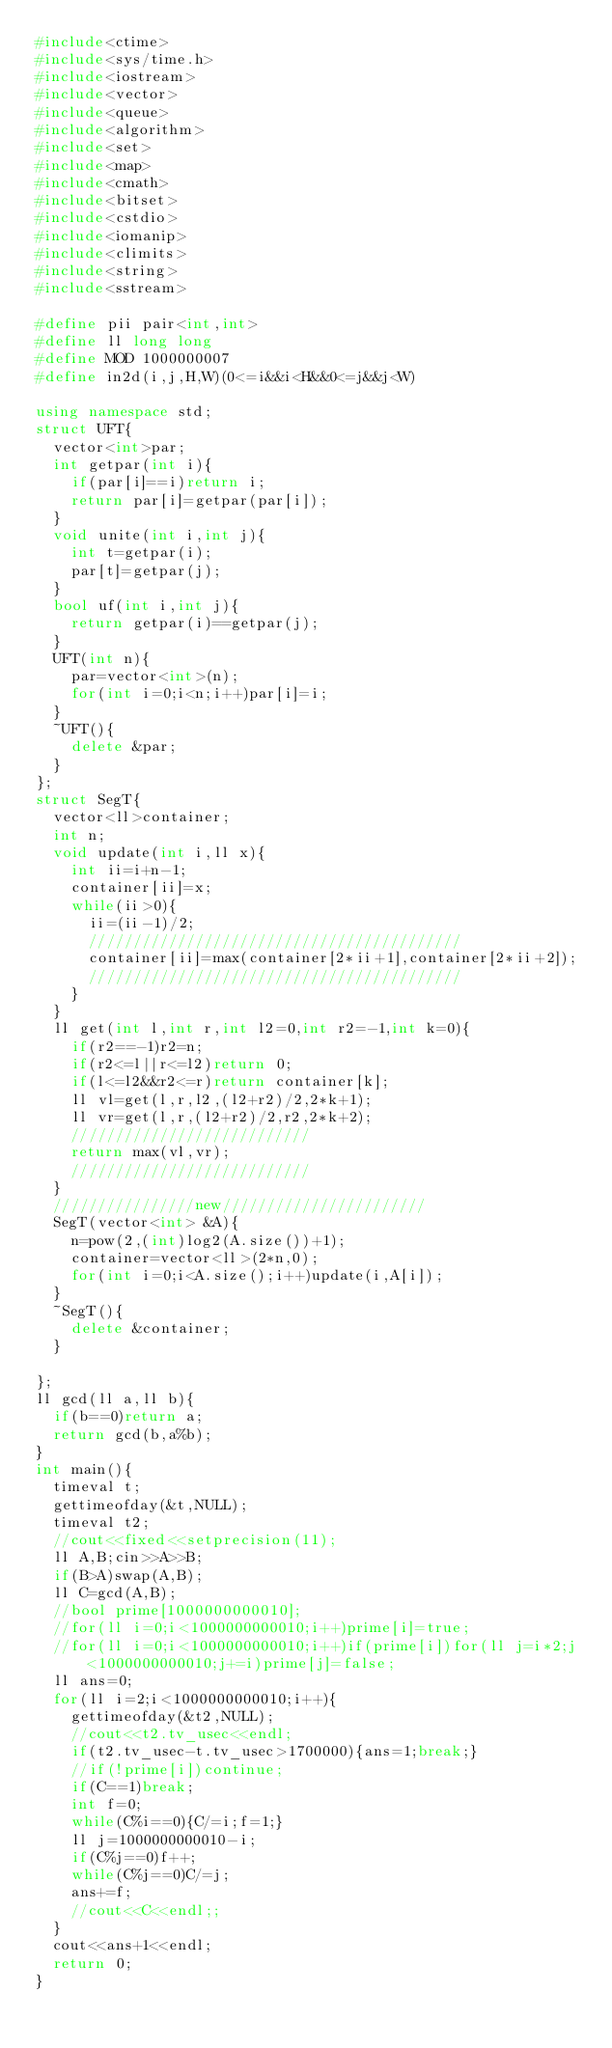<code> <loc_0><loc_0><loc_500><loc_500><_C++_>#include<ctime>
#include<sys/time.h>
#include<iostream>
#include<vector>
#include<queue>
#include<algorithm>
#include<set>
#include<map>
#include<cmath>
#include<bitset>
#include<cstdio>
#include<iomanip>
#include<climits>
#include<string>
#include<sstream>

#define pii pair<int,int>
#define ll long long
#define MOD 1000000007
#define in2d(i,j,H,W)(0<=i&&i<H&&0<=j&&j<W)

using namespace std;
struct UFT{
	vector<int>par;
	int getpar(int i){
		if(par[i]==i)return i;
		return par[i]=getpar(par[i]);
	}
	void unite(int i,int j){
		int t=getpar(i);
		par[t]=getpar(j);
	}
	bool uf(int i,int j){
		return getpar(i)==getpar(j);
	}
	UFT(int n){
		par=vector<int>(n);
		for(int i=0;i<n;i++)par[i]=i;
	}
	~UFT(){
		delete &par;
	}
};
struct SegT{
	vector<ll>container;
	int n;
	void update(int i,ll x){
		int ii=i+n-1;
		container[ii]=x;
		while(ii>0){
			ii=(ii-1)/2;
			//////////////////////////////////////////
			container[ii]=max(container[2*ii+1],container[2*ii+2]);
			//////////////////////////////////////////
		}
	}
	ll get(int l,int r,int l2=0,int r2=-1,int k=0){
		if(r2==-1)r2=n;
		if(r2<=l||r<=l2)return 0;
		if(l<=l2&&r2<=r)return container[k];
		ll vl=get(l,r,l2,(l2+r2)/2,2*k+1);
		ll vr=get(l,r,(l2+r2)/2,r2,2*k+2);
		///////////////////////////
		return max(vl,vr);
		///////////////////////////
	}
	////////////////new///////////////////////
	SegT(vector<int> &A){
		n=pow(2,(int)log2(A.size())+1);
		container=vector<ll>(2*n,0);
		for(int i=0;i<A.size();i++)update(i,A[i]);
	}
	~SegT(){
		delete &container;
	}

};
ll gcd(ll a,ll b){
	if(b==0)return a;
	return gcd(b,a%b);
}
int main(){
	timeval t;
	gettimeofday(&t,NULL);
	timeval t2;
	//cout<<fixed<<setprecision(11);
	ll A,B;cin>>A>>B;
	if(B>A)swap(A,B);
	ll C=gcd(A,B);
	//bool prime[1000000000010];
	//for(ll i=0;i<1000000000010;i++)prime[i]=true;
	//for(ll i=0;i<1000000000010;i++)if(prime[i])for(ll j=i*2;j<1000000000010;j+=i)prime[j]=false;
	ll ans=0;
	for(ll i=2;i<1000000000010;i++){
		gettimeofday(&t2,NULL);
		//cout<<t2.tv_usec<<endl;
		if(t2.tv_usec-t.tv_usec>1700000){ans=1;break;}
		//if(!prime[i])continue;
		if(C==1)break;
		int f=0;
		while(C%i==0){C/=i;f=1;}
		ll j=1000000000010-i;
		if(C%j==0)f++;
		while(C%j==0)C/=j;
		ans+=f;
		//cout<<C<<endl;;
	}
	cout<<ans+1<<endl;
	return 0;
}

</code> 